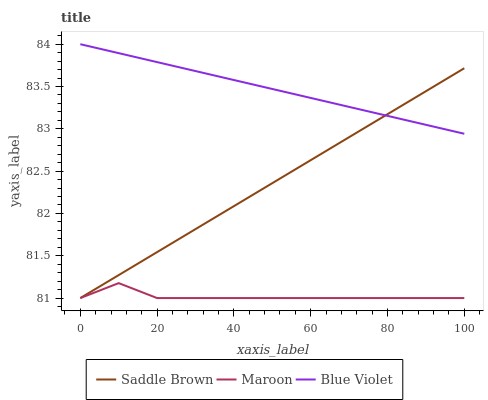Does Saddle Brown have the minimum area under the curve?
Answer yes or no. No. Does Saddle Brown have the maximum area under the curve?
Answer yes or no. No. Is Saddle Brown the smoothest?
Answer yes or no. No. Is Saddle Brown the roughest?
Answer yes or no. No. Does Saddle Brown have the highest value?
Answer yes or no. No. Is Maroon less than Blue Violet?
Answer yes or no. Yes. Is Blue Violet greater than Maroon?
Answer yes or no. Yes. Does Maroon intersect Blue Violet?
Answer yes or no. No. 